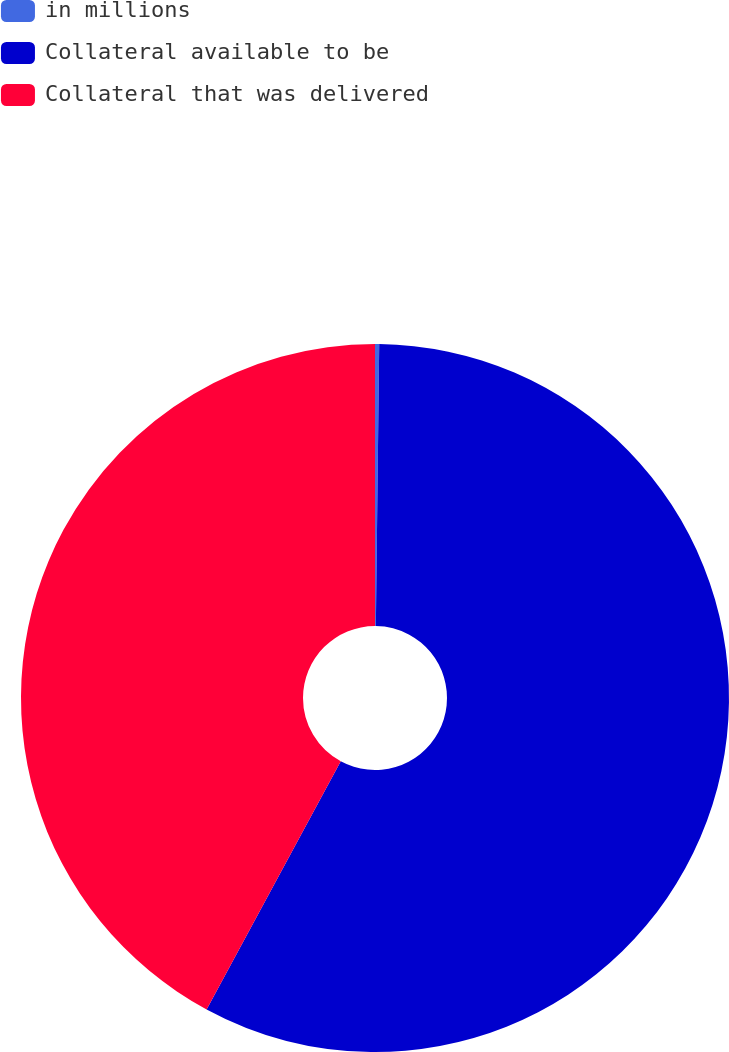Convert chart to OTSL. <chart><loc_0><loc_0><loc_500><loc_500><pie_chart><fcel>in millions<fcel>Collateral available to be<fcel>Collateral that was delivered<nl><fcel>0.19%<fcel>57.7%<fcel>42.11%<nl></chart> 